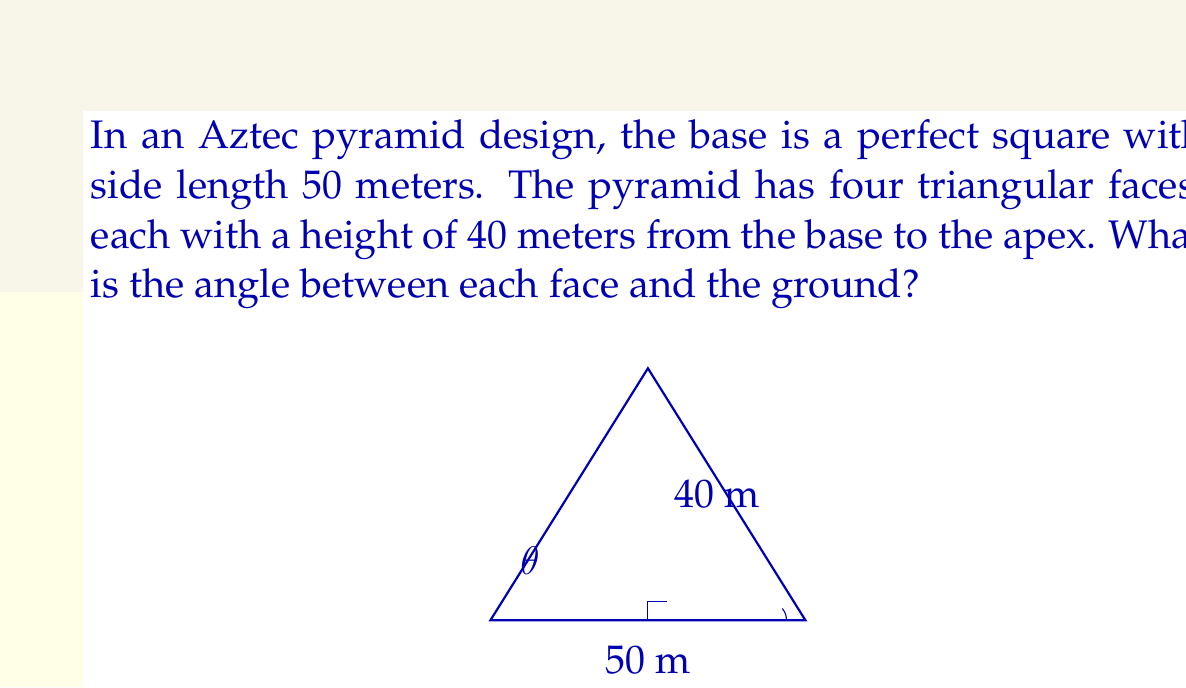Provide a solution to this math problem. Let's approach this step-by-step:

1) We can divide the pyramid into four congruent right triangles. Let's focus on one of these triangles.

2) In this right triangle:
   - The base is half of the square's side length: $\frac{50}{2} = 25$ meters
   - The height is given as 40 meters
   - We need to find the angle between this face and the ground, let's call it $\theta$

3) We can use the tangent function to find this angle:

   $\tan(\theta) = \frac{\text{opposite}}{\text{adjacent}} = \frac{40}{25}$

4) To find $\theta$, we need to use the inverse tangent (arctan) function:

   $\theta = \arctan(\frac{40}{25})$

5) Using a calculator or computer:

   $\theta \approx 57.99^\circ$

6) Round to two decimal places:

   $\theta \approx 58.00^\circ$

Thus, the angle between each face and the ground is approximately 58.00°.
Answer: $58.00^\circ$ 